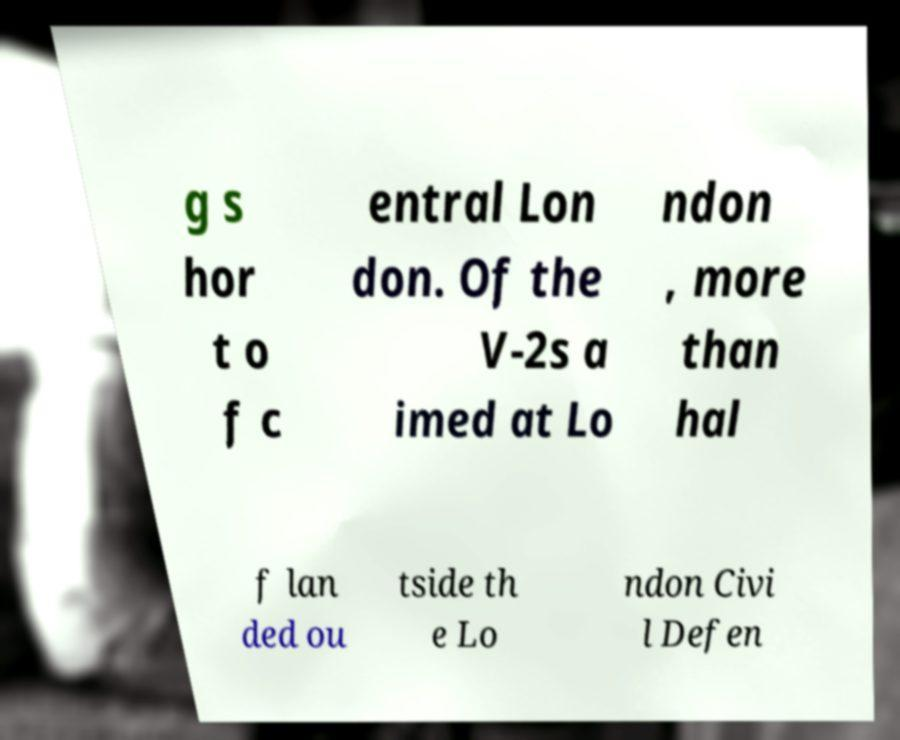I need the written content from this picture converted into text. Can you do that? g s hor t o f c entral Lon don. Of the V-2s a imed at Lo ndon , more than hal f lan ded ou tside th e Lo ndon Civi l Defen 